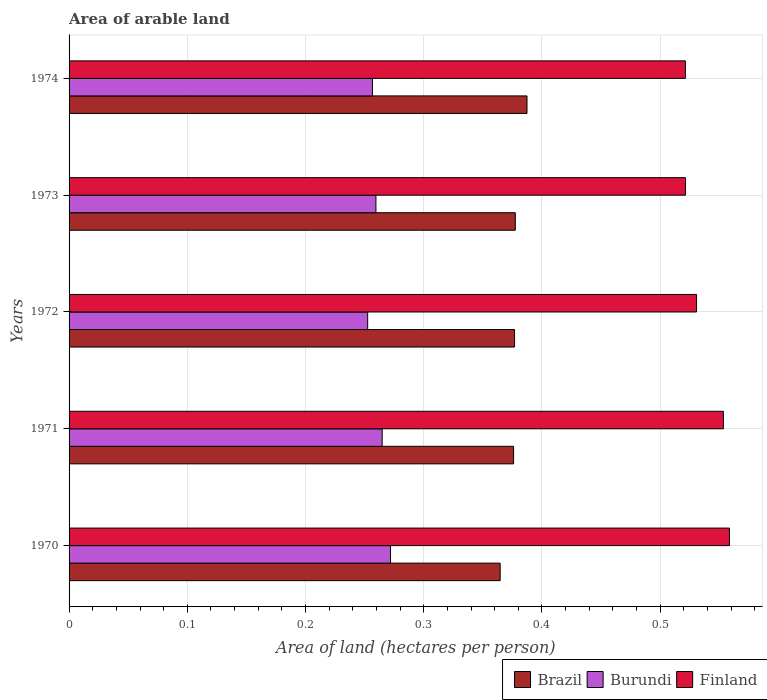Are the number of bars on each tick of the Y-axis equal?
Your answer should be compact. Yes. In how many cases, is the number of bars for a given year not equal to the number of legend labels?
Ensure brevity in your answer.  0. What is the total arable land in Burundi in 1971?
Provide a succinct answer. 0.26. Across all years, what is the maximum total arable land in Burundi?
Offer a very short reply. 0.27. Across all years, what is the minimum total arable land in Finland?
Provide a succinct answer. 0.52. In which year was the total arable land in Brazil maximum?
Your answer should be compact. 1974. In which year was the total arable land in Burundi minimum?
Offer a terse response. 1972. What is the total total arable land in Brazil in the graph?
Provide a short and direct response. 1.88. What is the difference between the total arable land in Burundi in 1972 and that in 1973?
Your answer should be compact. -0.01. What is the difference between the total arable land in Burundi in 1971 and the total arable land in Finland in 1973?
Provide a succinct answer. -0.26. What is the average total arable land in Brazil per year?
Keep it short and to the point. 0.38. In the year 1970, what is the difference between the total arable land in Burundi and total arable land in Brazil?
Your answer should be very brief. -0.09. What is the ratio of the total arable land in Finland in 1970 to that in 1974?
Provide a succinct answer. 1.07. Is the total arable land in Finland in 1971 less than that in 1974?
Provide a short and direct response. No. What is the difference between the highest and the second highest total arable land in Finland?
Your answer should be very brief. 0.01. What is the difference between the highest and the lowest total arable land in Finland?
Provide a succinct answer. 0.04. In how many years, is the total arable land in Burundi greater than the average total arable land in Burundi taken over all years?
Offer a very short reply. 2. Is the sum of the total arable land in Finland in 1972 and 1973 greater than the maximum total arable land in Burundi across all years?
Your answer should be very brief. Yes. What does the 1st bar from the top in 1971 represents?
Your answer should be very brief. Finland. How many bars are there?
Your response must be concise. 15. Are all the bars in the graph horizontal?
Make the answer very short. Yes. What is the difference between two consecutive major ticks on the X-axis?
Offer a very short reply. 0.1. Does the graph contain grids?
Provide a succinct answer. Yes. Where does the legend appear in the graph?
Provide a short and direct response. Bottom right. How many legend labels are there?
Provide a succinct answer. 3. How are the legend labels stacked?
Keep it short and to the point. Horizontal. What is the title of the graph?
Give a very brief answer. Area of arable land. Does "Cambodia" appear as one of the legend labels in the graph?
Provide a succinct answer. No. What is the label or title of the X-axis?
Your answer should be very brief. Area of land (hectares per person). What is the label or title of the Y-axis?
Offer a very short reply. Years. What is the Area of land (hectares per person) of Brazil in 1970?
Keep it short and to the point. 0.36. What is the Area of land (hectares per person) in Burundi in 1970?
Offer a terse response. 0.27. What is the Area of land (hectares per person) of Finland in 1970?
Your answer should be compact. 0.56. What is the Area of land (hectares per person) of Brazil in 1971?
Keep it short and to the point. 0.38. What is the Area of land (hectares per person) of Burundi in 1971?
Your response must be concise. 0.26. What is the Area of land (hectares per person) of Finland in 1971?
Provide a short and direct response. 0.55. What is the Area of land (hectares per person) in Brazil in 1972?
Your answer should be compact. 0.38. What is the Area of land (hectares per person) of Burundi in 1972?
Provide a short and direct response. 0.25. What is the Area of land (hectares per person) of Finland in 1972?
Make the answer very short. 0.53. What is the Area of land (hectares per person) of Brazil in 1973?
Offer a terse response. 0.38. What is the Area of land (hectares per person) in Burundi in 1973?
Offer a terse response. 0.26. What is the Area of land (hectares per person) of Finland in 1973?
Make the answer very short. 0.52. What is the Area of land (hectares per person) in Brazil in 1974?
Your answer should be compact. 0.39. What is the Area of land (hectares per person) in Burundi in 1974?
Your answer should be very brief. 0.26. What is the Area of land (hectares per person) in Finland in 1974?
Offer a very short reply. 0.52. Across all years, what is the maximum Area of land (hectares per person) in Brazil?
Make the answer very short. 0.39. Across all years, what is the maximum Area of land (hectares per person) of Burundi?
Provide a short and direct response. 0.27. Across all years, what is the maximum Area of land (hectares per person) in Finland?
Keep it short and to the point. 0.56. Across all years, what is the minimum Area of land (hectares per person) of Brazil?
Offer a terse response. 0.36. Across all years, what is the minimum Area of land (hectares per person) of Burundi?
Offer a terse response. 0.25. Across all years, what is the minimum Area of land (hectares per person) of Finland?
Provide a short and direct response. 0.52. What is the total Area of land (hectares per person) of Brazil in the graph?
Provide a short and direct response. 1.88. What is the total Area of land (hectares per person) in Burundi in the graph?
Ensure brevity in your answer.  1.31. What is the total Area of land (hectares per person) of Finland in the graph?
Provide a succinct answer. 2.69. What is the difference between the Area of land (hectares per person) of Brazil in 1970 and that in 1971?
Your answer should be compact. -0.01. What is the difference between the Area of land (hectares per person) of Burundi in 1970 and that in 1971?
Provide a short and direct response. 0.01. What is the difference between the Area of land (hectares per person) of Finland in 1970 and that in 1971?
Make the answer very short. 0.01. What is the difference between the Area of land (hectares per person) in Brazil in 1970 and that in 1972?
Your response must be concise. -0.01. What is the difference between the Area of land (hectares per person) in Burundi in 1970 and that in 1972?
Give a very brief answer. 0.02. What is the difference between the Area of land (hectares per person) in Finland in 1970 and that in 1972?
Offer a terse response. 0.03. What is the difference between the Area of land (hectares per person) of Brazil in 1970 and that in 1973?
Provide a short and direct response. -0.01. What is the difference between the Area of land (hectares per person) in Burundi in 1970 and that in 1973?
Give a very brief answer. 0.01. What is the difference between the Area of land (hectares per person) in Finland in 1970 and that in 1973?
Offer a very short reply. 0.04. What is the difference between the Area of land (hectares per person) of Brazil in 1970 and that in 1974?
Your response must be concise. -0.02. What is the difference between the Area of land (hectares per person) in Burundi in 1970 and that in 1974?
Give a very brief answer. 0.02. What is the difference between the Area of land (hectares per person) of Finland in 1970 and that in 1974?
Ensure brevity in your answer.  0.04. What is the difference between the Area of land (hectares per person) of Brazil in 1971 and that in 1972?
Make the answer very short. -0. What is the difference between the Area of land (hectares per person) in Burundi in 1971 and that in 1972?
Keep it short and to the point. 0.01. What is the difference between the Area of land (hectares per person) in Finland in 1971 and that in 1972?
Provide a short and direct response. 0.02. What is the difference between the Area of land (hectares per person) of Brazil in 1971 and that in 1973?
Your answer should be compact. -0. What is the difference between the Area of land (hectares per person) in Burundi in 1971 and that in 1973?
Your answer should be very brief. 0.01. What is the difference between the Area of land (hectares per person) of Finland in 1971 and that in 1973?
Your answer should be very brief. 0.03. What is the difference between the Area of land (hectares per person) of Brazil in 1971 and that in 1974?
Your answer should be very brief. -0.01. What is the difference between the Area of land (hectares per person) in Burundi in 1971 and that in 1974?
Ensure brevity in your answer.  0.01. What is the difference between the Area of land (hectares per person) of Finland in 1971 and that in 1974?
Keep it short and to the point. 0.03. What is the difference between the Area of land (hectares per person) of Brazil in 1972 and that in 1973?
Your answer should be compact. -0. What is the difference between the Area of land (hectares per person) of Burundi in 1972 and that in 1973?
Ensure brevity in your answer.  -0.01. What is the difference between the Area of land (hectares per person) in Finland in 1972 and that in 1973?
Your response must be concise. 0.01. What is the difference between the Area of land (hectares per person) in Brazil in 1972 and that in 1974?
Provide a short and direct response. -0.01. What is the difference between the Area of land (hectares per person) of Burundi in 1972 and that in 1974?
Make the answer very short. -0. What is the difference between the Area of land (hectares per person) of Finland in 1972 and that in 1974?
Offer a very short reply. 0.01. What is the difference between the Area of land (hectares per person) in Brazil in 1973 and that in 1974?
Provide a short and direct response. -0.01. What is the difference between the Area of land (hectares per person) of Burundi in 1973 and that in 1974?
Your response must be concise. 0. What is the difference between the Area of land (hectares per person) of Brazil in 1970 and the Area of land (hectares per person) of Burundi in 1971?
Your response must be concise. 0.1. What is the difference between the Area of land (hectares per person) of Brazil in 1970 and the Area of land (hectares per person) of Finland in 1971?
Offer a terse response. -0.19. What is the difference between the Area of land (hectares per person) in Burundi in 1970 and the Area of land (hectares per person) in Finland in 1971?
Provide a short and direct response. -0.28. What is the difference between the Area of land (hectares per person) in Brazil in 1970 and the Area of land (hectares per person) in Burundi in 1972?
Keep it short and to the point. 0.11. What is the difference between the Area of land (hectares per person) in Brazil in 1970 and the Area of land (hectares per person) in Finland in 1972?
Offer a very short reply. -0.17. What is the difference between the Area of land (hectares per person) of Burundi in 1970 and the Area of land (hectares per person) of Finland in 1972?
Keep it short and to the point. -0.26. What is the difference between the Area of land (hectares per person) of Brazil in 1970 and the Area of land (hectares per person) of Burundi in 1973?
Provide a succinct answer. 0.11. What is the difference between the Area of land (hectares per person) in Brazil in 1970 and the Area of land (hectares per person) in Finland in 1973?
Your response must be concise. -0.16. What is the difference between the Area of land (hectares per person) in Burundi in 1970 and the Area of land (hectares per person) in Finland in 1973?
Provide a short and direct response. -0.25. What is the difference between the Area of land (hectares per person) of Brazil in 1970 and the Area of land (hectares per person) of Burundi in 1974?
Make the answer very short. 0.11. What is the difference between the Area of land (hectares per person) in Brazil in 1970 and the Area of land (hectares per person) in Finland in 1974?
Offer a terse response. -0.16. What is the difference between the Area of land (hectares per person) in Burundi in 1970 and the Area of land (hectares per person) in Finland in 1974?
Make the answer very short. -0.25. What is the difference between the Area of land (hectares per person) in Brazil in 1971 and the Area of land (hectares per person) in Burundi in 1972?
Your answer should be compact. 0.12. What is the difference between the Area of land (hectares per person) in Brazil in 1971 and the Area of land (hectares per person) in Finland in 1972?
Provide a succinct answer. -0.15. What is the difference between the Area of land (hectares per person) in Burundi in 1971 and the Area of land (hectares per person) in Finland in 1972?
Provide a succinct answer. -0.27. What is the difference between the Area of land (hectares per person) in Brazil in 1971 and the Area of land (hectares per person) in Burundi in 1973?
Offer a very short reply. 0.12. What is the difference between the Area of land (hectares per person) in Brazil in 1971 and the Area of land (hectares per person) in Finland in 1973?
Offer a very short reply. -0.15. What is the difference between the Area of land (hectares per person) of Burundi in 1971 and the Area of land (hectares per person) of Finland in 1973?
Your answer should be very brief. -0.26. What is the difference between the Area of land (hectares per person) in Brazil in 1971 and the Area of land (hectares per person) in Burundi in 1974?
Keep it short and to the point. 0.12. What is the difference between the Area of land (hectares per person) of Brazil in 1971 and the Area of land (hectares per person) of Finland in 1974?
Ensure brevity in your answer.  -0.15. What is the difference between the Area of land (hectares per person) in Burundi in 1971 and the Area of land (hectares per person) in Finland in 1974?
Provide a succinct answer. -0.26. What is the difference between the Area of land (hectares per person) of Brazil in 1972 and the Area of land (hectares per person) of Burundi in 1973?
Offer a very short reply. 0.12. What is the difference between the Area of land (hectares per person) of Brazil in 1972 and the Area of land (hectares per person) of Finland in 1973?
Give a very brief answer. -0.14. What is the difference between the Area of land (hectares per person) of Burundi in 1972 and the Area of land (hectares per person) of Finland in 1973?
Give a very brief answer. -0.27. What is the difference between the Area of land (hectares per person) of Brazil in 1972 and the Area of land (hectares per person) of Burundi in 1974?
Keep it short and to the point. 0.12. What is the difference between the Area of land (hectares per person) of Brazil in 1972 and the Area of land (hectares per person) of Finland in 1974?
Provide a short and direct response. -0.14. What is the difference between the Area of land (hectares per person) of Burundi in 1972 and the Area of land (hectares per person) of Finland in 1974?
Keep it short and to the point. -0.27. What is the difference between the Area of land (hectares per person) of Brazil in 1973 and the Area of land (hectares per person) of Burundi in 1974?
Ensure brevity in your answer.  0.12. What is the difference between the Area of land (hectares per person) in Brazil in 1973 and the Area of land (hectares per person) in Finland in 1974?
Give a very brief answer. -0.14. What is the difference between the Area of land (hectares per person) in Burundi in 1973 and the Area of land (hectares per person) in Finland in 1974?
Your response must be concise. -0.26. What is the average Area of land (hectares per person) in Brazil per year?
Offer a very short reply. 0.38. What is the average Area of land (hectares per person) of Burundi per year?
Your response must be concise. 0.26. What is the average Area of land (hectares per person) in Finland per year?
Provide a short and direct response. 0.54. In the year 1970, what is the difference between the Area of land (hectares per person) in Brazil and Area of land (hectares per person) in Burundi?
Your answer should be compact. 0.09. In the year 1970, what is the difference between the Area of land (hectares per person) in Brazil and Area of land (hectares per person) in Finland?
Your answer should be compact. -0.19. In the year 1970, what is the difference between the Area of land (hectares per person) of Burundi and Area of land (hectares per person) of Finland?
Your answer should be very brief. -0.29. In the year 1971, what is the difference between the Area of land (hectares per person) in Brazil and Area of land (hectares per person) in Burundi?
Offer a terse response. 0.11. In the year 1971, what is the difference between the Area of land (hectares per person) of Brazil and Area of land (hectares per person) of Finland?
Your answer should be very brief. -0.18. In the year 1971, what is the difference between the Area of land (hectares per person) of Burundi and Area of land (hectares per person) of Finland?
Offer a very short reply. -0.29. In the year 1972, what is the difference between the Area of land (hectares per person) in Brazil and Area of land (hectares per person) in Burundi?
Provide a short and direct response. 0.12. In the year 1972, what is the difference between the Area of land (hectares per person) of Brazil and Area of land (hectares per person) of Finland?
Ensure brevity in your answer.  -0.15. In the year 1972, what is the difference between the Area of land (hectares per person) of Burundi and Area of land (hectares per person) of Finland?
Make the answer very short. -0.28. In the year 1973, what is the difference between the Area of land (hectares per person) of Brazil and Area of land (hectares per person) of Burundi?
Give a very brief answer. 0.12. In the year 1973, what is the difference between the Area of land (hectares per person) in Brazil and Area of land (hectares per person) in Finland?
Your answer should be very brief. -0.14. In the year 1973, what is the difference between the Area of land (hectares per person) in Burundi and Area of land (hectares per person) in Finland?
Your answer should be very brief. -0.26. In the year 1974, what is the difference between the Area of land (hectares per person) in Brazil and Area of land (hectares per person) in Burundi?
Your answer should be very brief. 0.13. In the year 1974, what is the difference between the Area of land (hectares per person) of Brazil and Area of land (hectares per person) of Finland?
Offer a very short reply. -0.13. In the year 1974, what is the difference between the Area of land (hectares per person) of Burundi and Area of land (hectares per person) of Finland?
Ensure brevity in your answer.  -0.26. What is the ratio of the Area of land (hectares per person) of Brazil in 1970 to that in 1971?
Ensure brevity in your answer.  0.97. What is the ratio of the Area of land (hectares per person) in Burundi in 1970 to that in 1971?
Offer a very short reply. 1.03. What is the ratio of the Area of land (hectares per person) of Finland in 1970 to that in 1971?
Provide a short and direct response. 1.01. What is the ratio of the Area of land (hectares per person) in Burundi in 1970 to that in 1972?
Your answer should be compact. 1.08. What is the ratio of the Area of land (hectares per person) of Finland in 1970 to that in 1972?
Offer a very short reply. 1.05. What is the ratio of the Area of land (hectares per person) of Brazil in 1970 to that in 1973?
Offer a terse response. 0.97. What is the ratio of the Area of land (hectares per person) of Burundi in 1970 to that in 1973?
Your answer should be very brief. 1.05. What is the ratio of the Area of land (hectares per person) of Finland in 1970 to that in 1973?
Offer a terse response. 1.07. What is the ratio of the Area of land (hectares per person) of Brazil in 1970 to that in 1974?
Make the answer very short. 0.94. What is the ratio of the Area of land (hectares per person) in Burundi in 1970 to that in 1974?
Offer a very short reply. 1.06. What is the ratio of the Area of land (hectares per person) of Finland in 1970 to that in 1974?
Offer a very short reply. 1.07. What is the ratio of the Area of land (hectares per person) of Burundi in 1971 to that in 1972?
Your response must be concise. 1.05. What is the ratio of the Area of land (hectares per person) in Finland in 1971 to that in 1972?
Provide a succinct answer. 1.04. What is the ratio of the Area of land (hectares per person) in Brazil in 1971 to that in 1973?
Give a very brief answer. 1. What is the ratio of the Area of land (hectares per person) of Burundi in 1971 to that in 1973?
Offer a terse response. 1.02. What is the ratio of the Area of land (hectares per person) in Finland in 1971 to that in 1973?
Provide a short and direct response. 1.06. What is the ratio of the Area of land (hectares per person) of Brazil in 1971 to that in 1974?
Your answer should be very brief. 0.97. What is the ratio of the Area of land (hectares per person) in Burundi in 1971 to that in 1974?
Make the answer very short. 1.03. What is the ratio of the Area of land (hectares per person) in Finland in 1971 to that in 1974?
Offer a very short reply. 1.06. What is the ratio of the Area of land (hectares per person) of Burundi in 1972 to that in 1973?
Provide a succinct answer. 0.97. What is the ratio of the Area of land (hectares per person) of Finland in 1972 to that in 1973?
Give a very brief answer. 1.02. What is the ratio of the Area of land (hectares per person) of Brazil in 1972 to that in 1974?
Give a very brief answer. 0.97. What is the ratio of the Area of land (hectares per person) of Burundi in 1972 to that in 1974?
Provide a short and direct response. 0.98. What is the ratio of the Area of land (hectares per person) in Finland in 1972 to that in 1974?
Offer a terse response. 1.02. What is the ratio of the Area of land (hectares per person) of Brazil in 1973 to that in 1974?
Make the answer very short. 0.97. What is the ratio of the Area of land (hectares per person) in Burundi in 1973 to that in 1974?
Give a very brief answer. 1.01. What is the ratio of the Area of land (hectares per person) in Finland in 1973 to that in 1974?
Offer a terse response. 1. What is the difference between the highest and the second highest Area of land (hectares per person) in Brazil?
Provide a short and direct response. 0.01. What is the difference between the highest and the second highest Area of land (hectares per person) of Burundi?
Give a very brief answer. 0.01. What is the difference between the highest and the second highest Area of land (hectares per person) in Finland?
Offer a very short reply. 0.01. What is the difference between the highest and the lowest Area of land (hectares per person) of Brazil?
Keep it short and to the point. 0.02. What is the difference between the highest and the lowest Area of land (hectares per person) in Burundi?
Offer a very short reply. 0.02. What is the difference between the highest and the lowest Area of land (hectares per person) of Finland?
Provide a short and direct response. 0.04. 